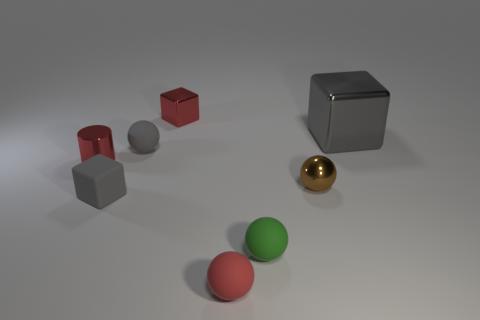What is the material of the red block that is the same size as the brown sphere?
Provide a short and direct response. Metal. Does the cube that is behind the gray shiny cube have the same color as the shiny thing that is left of the red metal cube?
Ensure brevity in your answer.  Yes. There is a metallic block to the left of the brown shiny ball; are there any red objects that are behind it?
Offer a very short reply. No. There is a small red object in front of the tiny brown object; does it have the same shape as the gray rubber thing that is behind the tiny red cylinder?
Ensure brevity in your answer.  Yes. Is the small cube that is behind the tiny red metallic cylinder made of the same material as the red object in front of the tiny brown sphere?
Ensure brevity in your answer.  No. What material is the red thing that is on the right side of the red object behind the red cylinder?
Give a very brief answer. Rubber. What shape is the shiny object to the left of the tiny cube behind the tiny block in front of the red cylinder?
Your answer should be compact. Cylinder. There is another gray thing that is the same shape as the large gray shiny object; what is it made of?
Keep it short and to the point. Rubber. How many gray objects are there?
Your answer should be very brief. 3. What is the shape of the tiny red metal object in front of the gray shiny object?
Keep it short and to the point. Cylinder. 